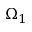<formula> <loc_0><loc_0><loc_500><loc_500>\Omega _ { 1 }</formula> 